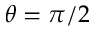<formula> <loc_0><loc_0><loc_500><loc_500>\theta = \pi / 2</formula> 